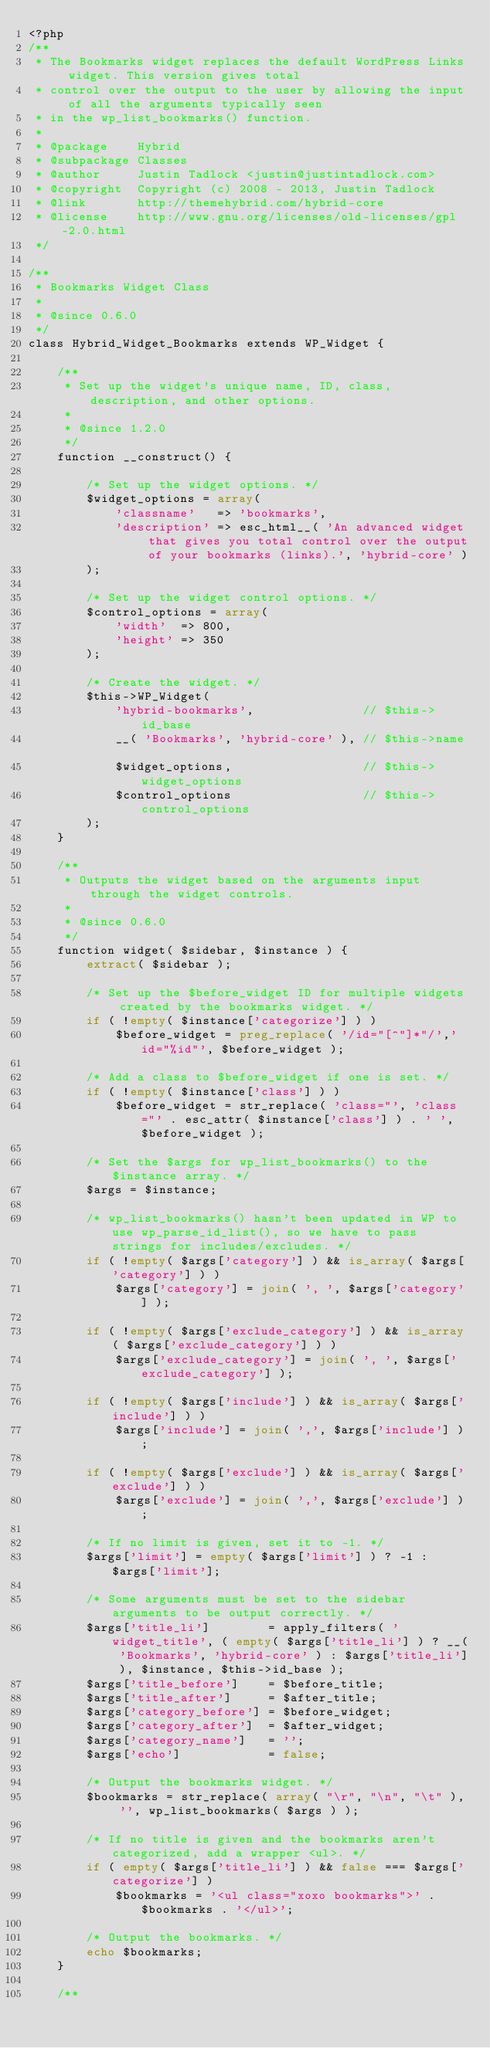Convert code to text. <code><loc_0><loc_0><loc_500><loc_500><_PHP_><?php
/**
 * The Bookmarks widget replaces the default WordPress Links widget. This version gives total
 * control over the output to the user by allowing the input of all the arguments typically seen
 * in the wp_list_bookmarks() function.
 *
 * @package    Hybrid
 * @subpackage Classes
 * @author     Justin Tadlock <justin@justintadlock.com>
 * @copyright  Copyright (c) 2008 - 2013, Justin Tadlock
 * @link       http://themehybrid.com/hybrid-core
 * @license    http://www.gnu.org/licenses/old-licenses/gpl-2.0.html
 */

/**
 * Bookmarks Widget Class
 *
 * @since 0.6.0
 */
class Hybrid_Widget_Bookmarks extends WP_Widget {

	/**
	 * Set up the widget's unique name, ID, class, description, and other options.
	 *
	 * @since 1.2.0
	 */
	function __construct() {

		/* Set up the widget options. */
		$widget_options = array(
			'classname'   => 'bookmarks',
			'description' => esc_html__( 'An advanced widget that gives you total control over the output of your bookmarks (links).', 'hybrid-core' )
		);

		/* Set up the widget control options. */
		$control_options = array(
			'width'  => 800,
			'height' => 350
		);

		/* Create the widget. */
		$this->WP_Widget(
			'hybrid-bookmarks',               // $this->id_base
			__( 'Bookmarks', 'hybrid-core' ), // $this->name	
			$widget_options,                  // $this->widget_options
			$control_options                  // $this->control_options
		);
	}

	/**
	 * Outputs the widget based on the arguments input through the widget controls.
	 *
	 * @since 0.6.0
	 */
	function widget( $sidebar, $instance ) {
		extract( $sidebar );

		/* Set up the $before_widget ID for multiple widgets created by the bookmarks widget. */
		if ( !empty( $instance['categorize'] ) )
			$before_widget = preg_replace( '/id="[^"]*"/','id="%id"', $before_widget );

		/* Add a class to $before_widget if one is set. */
		if ( !empty( $instance['class'] ) )
			$before_widget = str_replace( 'class="', 'class="' . esc_attr( $instance['class'] ) . ' ', $before_widget );

		/* Set the $args for wp_list_bookmarks() to the $instance array. */
		$args = $instance;

		/* wp_list_bookmarks() hasn't been updated in WP to use wp_parse_id_list(), so we have to pass strings for includes/excludes. */
		if ( !empty( $args['category'] ) && is_array( $args['category'] ) )
			$args['category'] = join( ', ', $args['category'] );

		if ( !empty( $args['exclude_category'] ) && is_array( $args['exclude_category'] ) )
			$args['exclude_category'] = join( ', ', $args['exclude_category'] );

		if ( !empty( $args['include'] ) && is_array( $args['include'] ) )
			$args['include'] = join( ',', $args['include'] );

		if ( !empty( $args['exclude'] ) && is_array( $args['exclude'] ) )
			$args['exclude'] = join( ',', $args['exclude'] );

		/* If no limit is given, set it to -1. */
		$args['limit'] = empty( $args['limit'] ) ? -1 : $args['limit'];

		/* Some arguments must be set to the sidebar arguments to be output correctly. */
		$args['title_li']        = apply_filters( 'widget_title', ( empty( $args['title_li'] ) ? __( 'Bookmarks', 'hybrid-core' ) : $args['title_li'] ), $instance, $this->id_base );
		$args['title_before']    = $before_title;
		$args['title_after']     = $after_title;
		$args['category_before'] = $before_widget;
		$args['category_after']  = $after_widget;
		$args['category_name']   = '';
		$args['echo']            = false;

		/* Output the bookmarks widget. */
		$bookmarks = str_replace( array( "\r", "\n", "\t" ), '', wp_list_bookmarks( $args ) );

		/* If no title is given and the bookmarks aren't categorized, add a wrapper <ul>. */
		if ( empty( $args['title_li'] ) && false === $args['categorize'] )
			$bookmarks = '<ul class="xoxo bookmarks">' . $bookmarks . '</ul>';

		/* Output the bookmarks. */
		echo $bookmarks;
	}

	/**</code> 